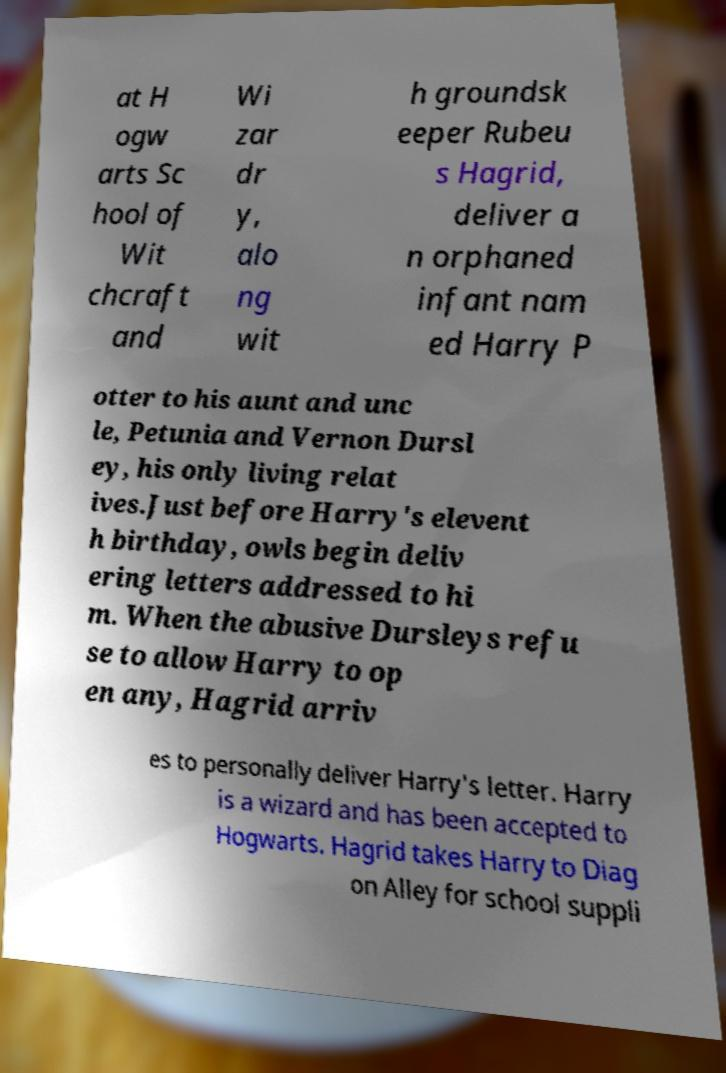Could you extract and type out the text from this image? at H ogw arts Sc hool of Wit chcraft and Wi zar dr y, alo ng wit h groundsk eeper Rubeu s Hagrid, deliver a n orphaned infant nam ed Harry P otter to his aunt and unc le, Petunia and Vernon Dursl ey, his only living relat ives.Just before Harry's elevent h birthday, owls begin deliv ering letters addressed to hi m. When the abusive Dursleys refu se to allow Harry to op en any, Hagrid arriv es to personally deliver Harry's letter. Harry is a wizard and has been accepted to Hogwarts. Hagrid takes Harry to Diag on Alley for school suppli 